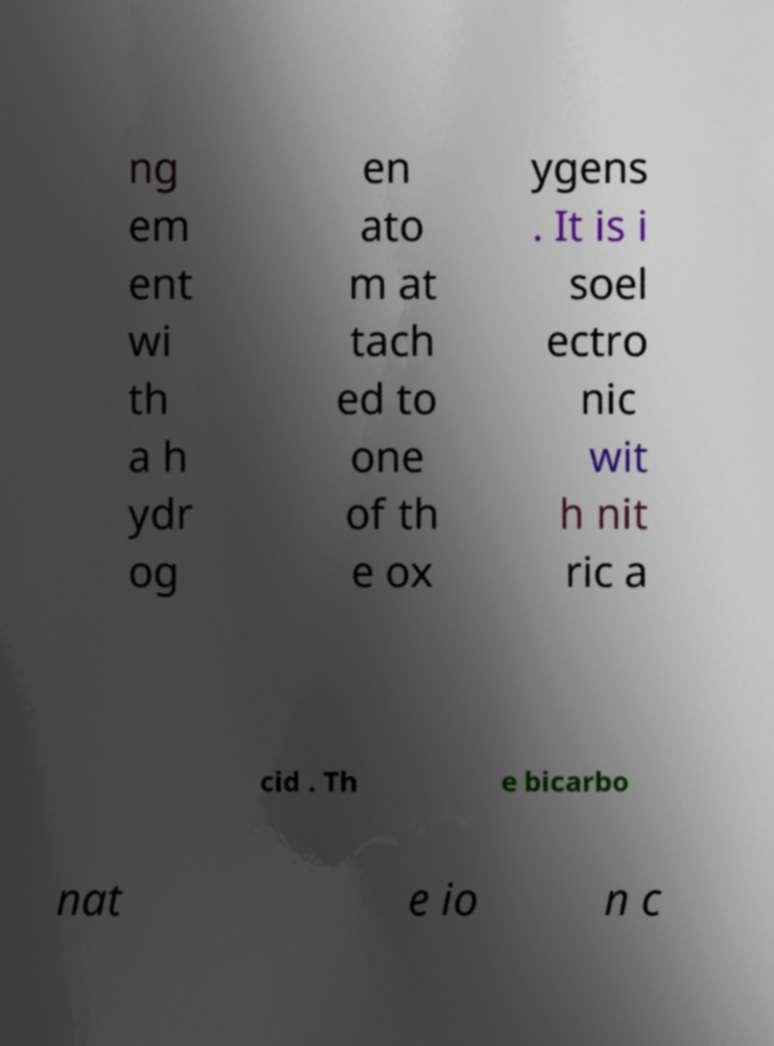What messages or text are displayed in this image? I need them in a readable, typed format. ng em ent wi th a h ydr og en ato m at tach ed to one of th e ox ygens . It is i soel ectro nic wit h nit ric a cid . Th e bicarbo nat e io n c 